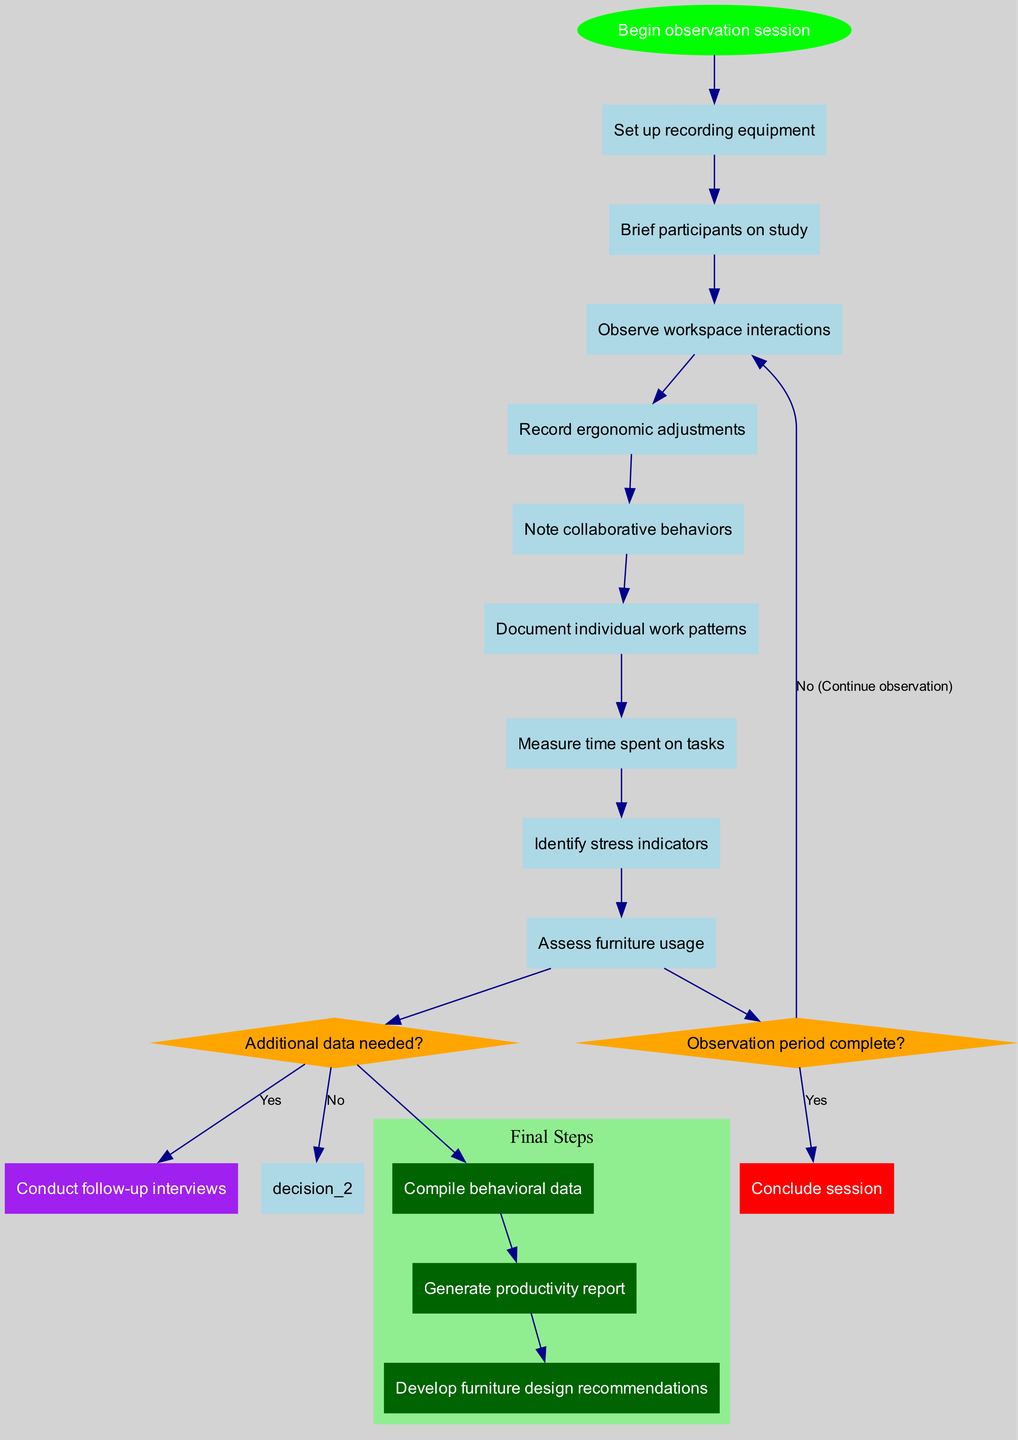what is the starting node of the diagram? The starting node is labeled "Begin observation session," which is identified as the first node in the diagram.
Answer: Begin observation session how many activities are there in total? There are ten activities listed in the diagram, counting each distinct action taken during the observation workflow.
Answer: 10 what happens if the observation period is complete? If the observation period is complete, the flow leads to the end node to "Conclude session," as indicated by the 'yes' path from the decision node.
Answer: Conclude session what is the decision point regarding additional data? The decision point is whether "Additional data needed?" which is a critical decision in the workflow that follows the observation activities.
Answer: Additional data needed? how many end nodes are present in the workflow? There are three end nodes that represent different outcomes of the workflow, each indicating a final product of the observation process.
Answer: 3 if the answer is yes to needing additional data, what action follows? If additional data is needed (the answer is yes), the workflow leads to "Conduct follow-up interviews," which is part of the decision logic shown in the diagram.
Answer: Conduct follow-up interviews what is the final outcome if there is no need for additional data? If there is no need for additional data, the workflow proceeds directly to "Proceed to data analysis," which implies moving to another phase of the study.
Answer: Proceed to data analysis describe the relationship between "Observe workspace interactions" and "Record ergonomic adjustments." "Observe workspace interactions" is an activity that precedes "Record ergonomic adjustments" in the workflow; they are sequential activities connected in the diagram.
Answer: Sequential activities what color represents the starting node? The starting node, "Begin observation session," is represented in green in the diagram, indicating its significance as the entry point.
Answer: Green 